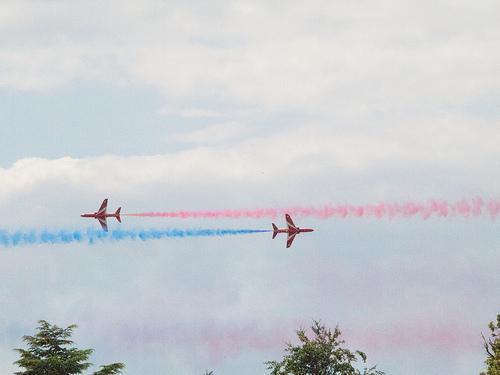How many planes are there?
Give a very brief answer. 2. 